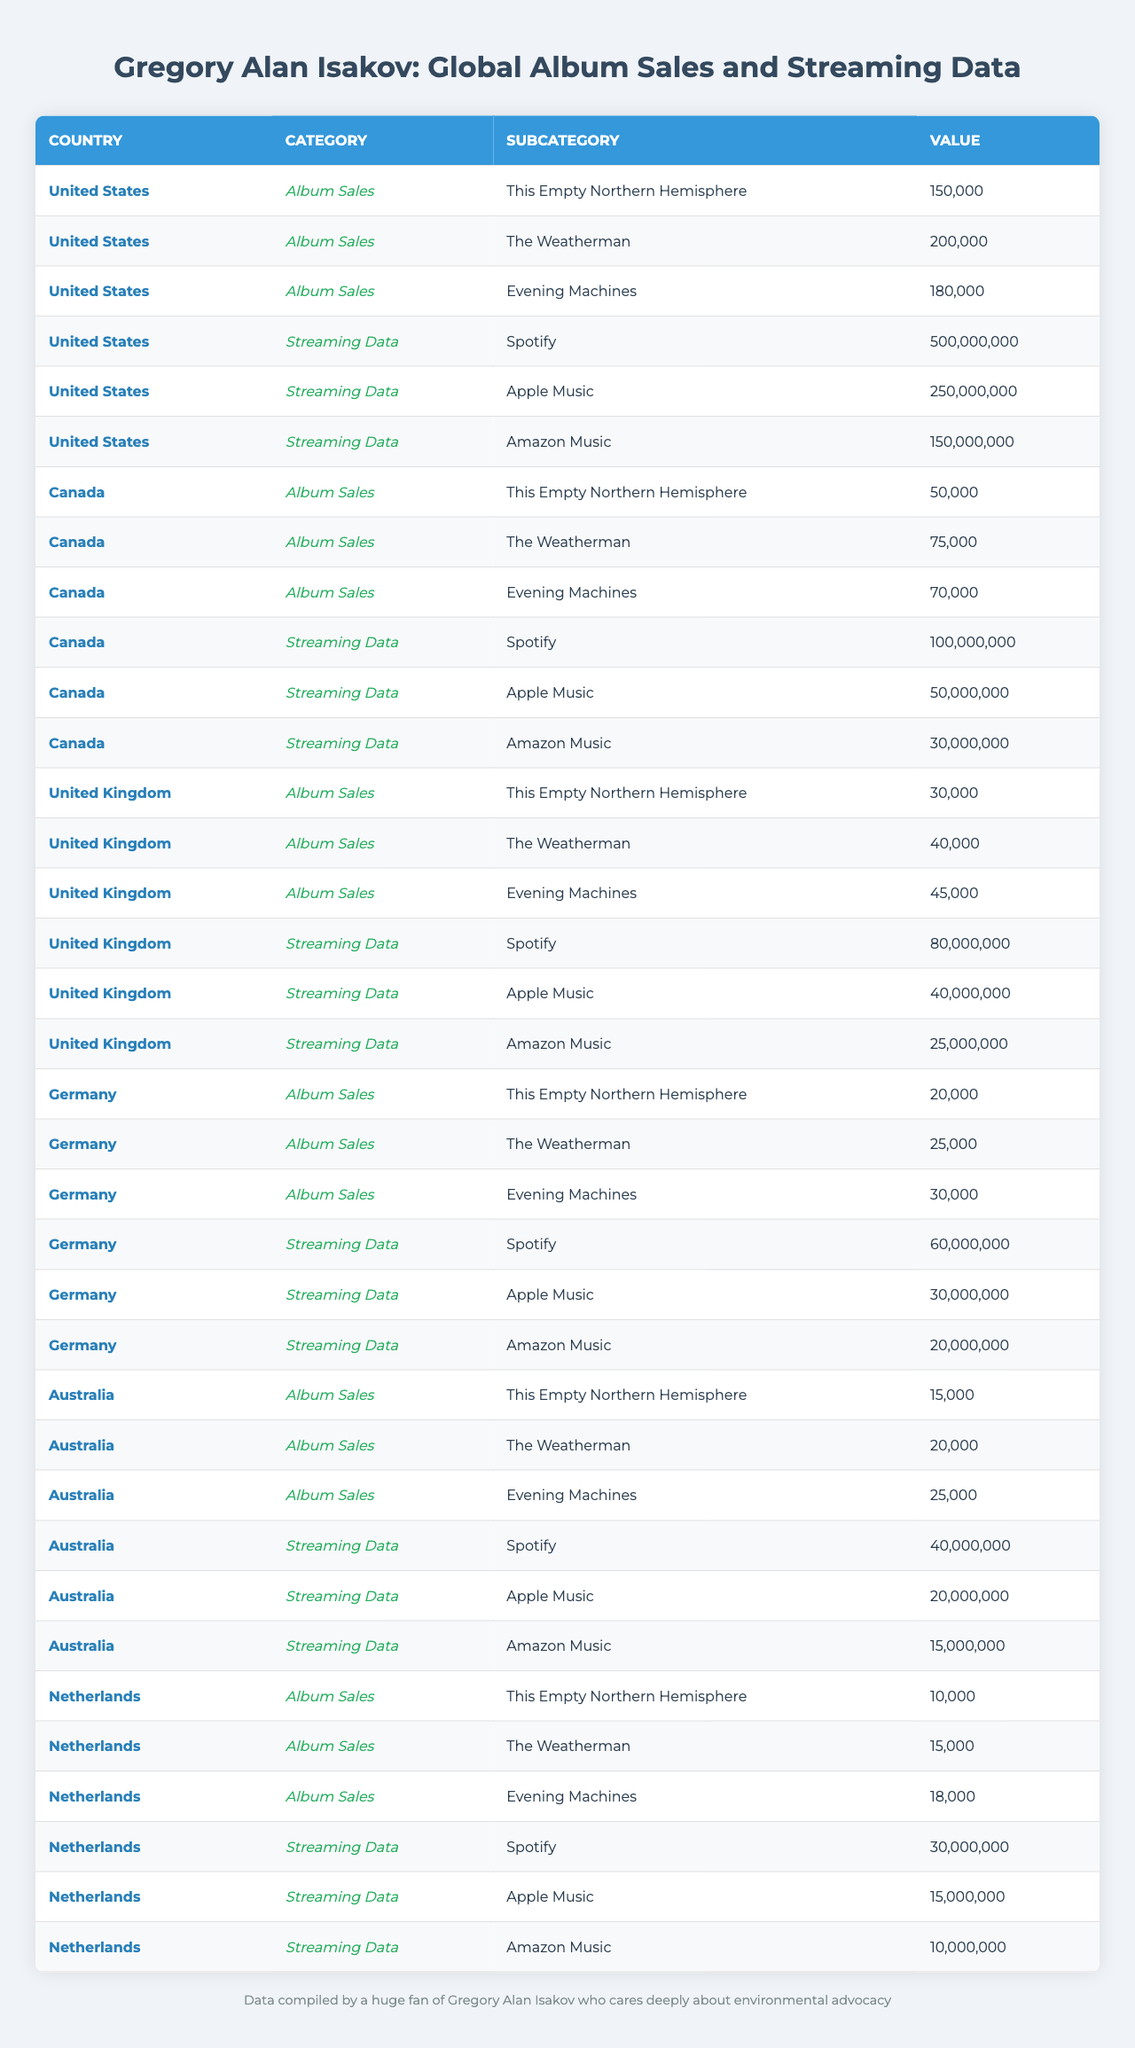What are the total album sales for Gregory Alan Isakov in the United States? The album sales in the United States can be calculated by summing the sales of each album: 150000 + 200000 + 180000 = 530000.
Answer: 530000 Which country has the highest Spotify streaming numbers for Gregory Alan Isakov? The highest Spotify streaming numbers can be found by comparing the Spotify streaming values: United States (500000000), Canada (100000000), United Kingdom (80000000), Germany (60000000), Australia (40000000), Netherlands (30000000). The United States has the highest number.
Answer: United States What is the average album sales in Canada for Gregory Alan Isakov? To find the average, we first sum the album sales in Canada: 50000 + 75000 + 70000 = 195000. There are 3 albums, so we divide the total by 3: 195000 / 3 = 65000.
Answer: 65000 Did Germany have higher album sales than the Netherlands for "Evening Machines"? The album sales for Germany's "Evening Machines" is 30000, while for the Netherlands, it is 18000. Since 30000 is greater than 18000, the statement is true.
Answer: Yes Calculate the total streaming data for all music platforms in Australia. To calculate the total streaming in Australia, add the values from each platform: 40000000 (Spotify) + 20000000 (Apple Music) + 15000000 (Amazon Music) = 75000000.
Answer: 75000000 What country had the least album sales for "This Empty Northern Hemisphere"? Comparing the album sales for "This Empty Northern Hemisphere": United States (150000), Canada (50000), United Kingdom (30000), Germany (20000), Australia (15000), Netherlands (10000), we find that the Netherlands had the least.
Answer: Netherlands Does the United Kingdom have higher album sales for "The Weatherman" than Canada? The United Kingdom's album sales for "The Weatherman" is 40000, while Canada has 75000. Since 40000 is less than 75000, the statement is false.
Answer: No How much more streaming data does the United States have compared to Germany across all platforms? First, calculate the total for each country. United States total: 500000000 (Spotify) + 250000000 (Apple Music) + 150000000 (Amazon Music) = 900000000. Germany total: 60000000 (Spotify) + 30000000 (Apple Music) + 20000000 (Amazon Music) = 110000000. The difference is 900000000 - 110000000 = 790000000.
Answer: 790000000 What is the total album sales for "Evening Machines" across all the countries listed? The total album sales for "Evening Machines" can be calculated by summing the sales from each country: 180000 (US) + 70000 (Canada) + 45000 (UK) + 30000 (Germany) + 25000 (Australia) + 18000 (Netherlands) = 380000.
Answer: 380000 Which country has the lowest total streaming data from the provided metrics? Adding up the total streaming data for each country gives us the following: United States (900000000), Canada (100000000), United Kingdom (80000000), Germany (60000000), Australia (40000000), Netherlands (30000000). The lowest is Netherlands with 30000000.
Answer: Netherlands 